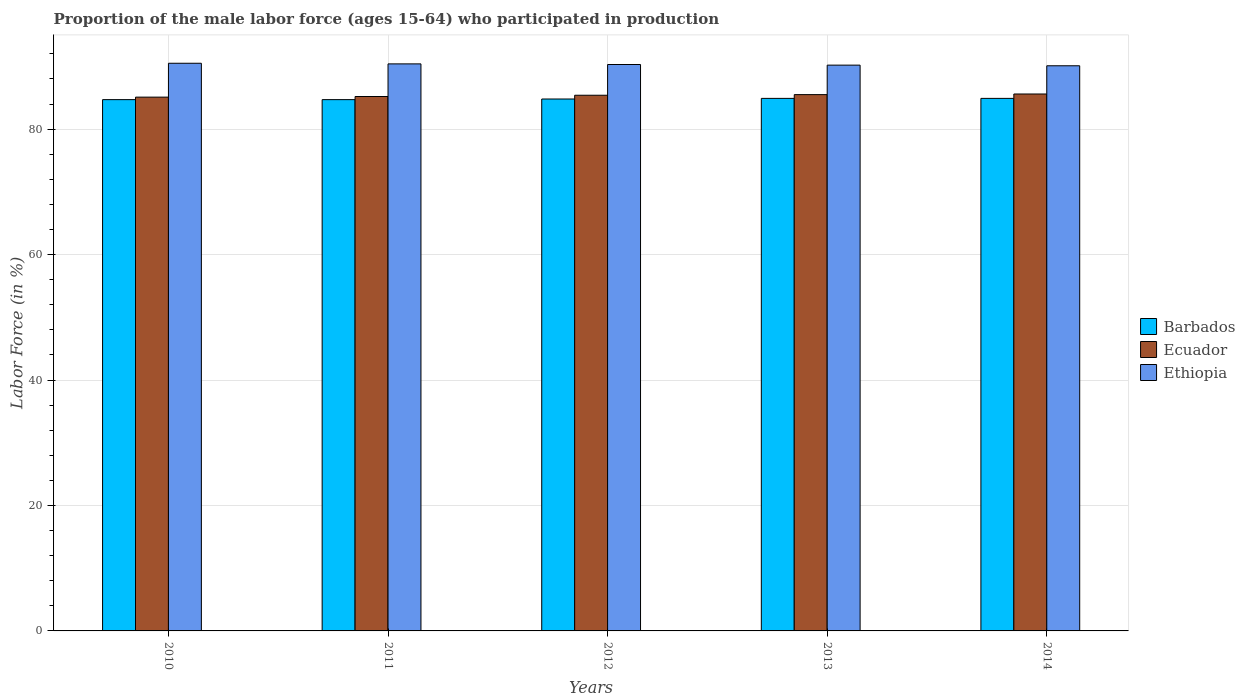How many groups of bars are there?
Your answer should be very brief. 5. Are the number of bars per tick equal to the number of legend labels?
Your answer should be very brief. Yes. Are the number of bars on each tick of the X-axis equal?
Your answer should be very brief. Yes. How many bars are there on the 3rd tick from the left?
Offer a very short reply. 3. In how many cases, is the number of bars for a given year not equal to the number of legend labels?
Your answer should be compact. 0. What is the proportion of the male labor force who participated in production in Barbados in 2012?
Offer a terse response. 84.8. Across all years, what is the maximum proportion of the male labor force who participated in production in Barbados?
Ensure brevity in your answer.  84.9. Across all years, what is the minimum proportion of the male labor force who participated in production in Barbados?
Ensure brevity in your answer.  84.7. In which year was the proportion of the male labor force who participated in production in Ethiopia maximum?
Ensure brevity in your answer.  2010. In which year was the proportion of the male labor force who participated in production in Barbados minimum?
Your answer should be compact. 2010. What is the total proportion of the male labor force who participated in production in Ethiopia in the graph?
Your answer should be compact. 451.5. What is the difference between the proportion of the male labor force who participated in production in Ethiopia in 2010 and that in 2012?
Provide a succinct answer. 0.2. What is the difference between the proportion of the male labor force who participated in production in Barbados in 2012 and the proportion of the male labor force who participated in production in Ethiopia in 2013?
Keep it short and to the point. -5.4. What is the average proportion of the male labor force who participated in production in Barbados per year?
Your answer should be compact. 84.8. In the year 2013, what is the difference between the proportion of the male labor force who participated in production in Barbados and proportion of the male labor force who participated in production in Ecuador?
Provide a succinct answer. -0.6. In how many years, is the proportion of the male labor force who participated in production in Ethiopia greater than 16 %?
Give a very brief answer. 5. What is the ratio of the proportion of the male labor force who participated in production in Barbados in 2011 to that in 2012?
Your answer should be very brief. 1. Is the difference between the proportion of the male labor force who participated in production in Barbados in 2010 and 2014 greater than the difference between the proportion of the male labor force who participated in production in Ecuador in 2010 and 2014?
Provide a short and direct response. Yes. What is the difference between the highest and the second highest proportion of the male labor force who participated in production in Ecuador?
Provide a succinct answer. 0.1. What is the difference between the highest and the lowest proportion of the male labor force who participated in production in Ethiopia?
Your response must be concise. 0.4. What does the 1st bar from the left in 2013 represents?
Your answer should be very brief. Barbados. What does the 1st bar from the right in 2010 represents?
Give a very brief answer. Ethiopia. Is it the case that in every year, the sum of the proportion of the male labor force who participated in production in Ethiopia and proportion of the male labor force who participated in production in Barbados is greater than the proportion of the male labor force who participated in production in Ecuador?
Your response must be concise. Yes. How many bars are there?
Ensure brevity in your answer.  15. Are all the bars in the graph horizontal?
Offer a terse response. No. How many years are there in the graph?
Your answer should be very brief. 5. Are the values on the major ticks of Y-axis written in scientific E-notation?
Ensure brevity in your answer.  No. Does the graph contain any zero values?
Make the answer very short. No. Where does the legend appear in the graph?
Provide a short and direct response. Center right. What is the title of the graph?
Ensure brevity in your answer.  Proportion of the male labor force (ages 15-64) who participated in production. What is the label or title of the X-axis?
Your response must be concise. Years. What is the Labor Force (in %) of Barbados in 2010?
Make the answer very short. 84.7. What is the Labor Force (in %) of Ecuador in 2010?
Make the answer very short. 85.1. What is the Labor Force (in %) in Ethiopia in 2010?
Give a very brief answer. 90.5. What is the Labor Force (in %) of Barbados in 2011?
Offer a terse response. 84.7. What is the Labor Force (in %) of Ecuador in 2011?
Make the answer very short. 85.2. What is the Labor Force (in %) in Ethiopia in 2011?
Offer a very short reply. 90.4. What is the Labor Force (in %) of Barbados in 2012?
Your answer should be very brief. 84.8. What is the Labor Force (in %) in Ecuador in 2012?
Keep it short and to the point. 85.4. What is the Labor Force (in %) in Ethiopia in 2012?
Offer a terse response. 90.3. What is the Labor Force (in %) of Barbados in 2013?
Make the answer very short. 84.9. What is the Labor Force (in %) of Ecuador in 2013?
Your answer should be compact. 85.5. What is the Labor Force (in %) in Ethiopia in 2013?
Your answer should be very brief. 90.2. What is the Labor Force (in %) in Barbados in 2014?
Ensure brevity in your answer.  84.9. What is the Labor Force (in %) of Ecuador in 2014?
Your response must be concise. 85.6. What is the Labor Force (in %) in Ethiopia in 2014?
Offer a terse response. 90.1. Across all years, what is the maximum Labor Force (in %) in Barbados?
Your answer should be compact. 84.9. Across all years, what is the maximum Labor Force (in %) in Ecuador?
Ensure brevity in your answer.  85.6. Across all years, what is the maximum Labor Force (in %) of Ethiopia?
Offer a terse response. 90.5. Across all years, what is the minimum Labor Force (in %) of Barbados?
Ensure brevity in your answer.  84.7. Across all years, what is the minimum Labor Force (in %) in Ecuador?
Provide a succinct answer. 85.1. Across all years, what is the minimum Labor Force (in %) of Ethiopia?
Keep it short and to the point. 90.1. What is the total Labor Force (in %) in Barbados in the graph?
Give a very brief answer. 424. What is the total Labor Force (in %) in Ecuador in the graph?
Your answer should be compact. 426.8. What is the total Labor Force (in %) in Ethiopia in the graph?
Give a very brief answer. 451.5. What is the difference between the Labor Force (in %) of Ethiopia in 2010 and that in 2011?
Give a very brief answer. 0.1. What is the difference between the Labor Force (in %) of Ethiopia in 2010 and that in 2014?
Make the answer very short. 0.4. What is the difference between the Labor Force (in %) in Ecuador in 2011 and that in 2012?
Give a very brief answer. -0.2. What is the difference between the Labor Force (in %) of Ethiopia in 2011 and that in 2012?
Ensure brevity in your answer.  0.1. What is the difference between the Labor Force (in %) in Ethiopia in 2011 and that in 2014?
Give a very brief answer. 0.3. What is the difference between the Labor Force (in %) in Barbados in 2012 and that in 2013?
Your answer should be very brief. -0.1. What is the difference between the Labor Force (in %) in Barbados in 2012 and that in 2014?
Provide a succinct answer. -0.1. What is the difference between the Labor Force (in %) of Ecuador in 2012 and that in 2014?
Give a very brief answer. -0.2. What is the difference between the Labor Force (in %) of Ethiopia in 2012 and that in 2014?
Offer a very short reply. 0.2. What is the difference between the Labor Force (in %) of Barbados in 2013 and that in 2014?
Ensure brevity in your answer.  0. What is the difference between the Labor Force (in %) in Ethiopia in 2013 and that in 2014?
Give a very brief answer. 0.1. What is the difference between the Labor Force (in %) of Barbados in 2010 and the Labor Force (in %) of Ecuador in 2011?
Provide a succinct answer. -0.5. What is the difference between the Labor Force (in %) of Ecuador in 2010 and the Labor Force (in %) of Ethiopia in 2011?
Provide a short and direct response. -5.3. What is the difference between the Labor Force (in %) of Barbados in 2010 and the Labor Force (in %) of Ethiopia in 2012?
Make the answer very short. -5.6. What is the difference between the Labor Force (in %) in Ecuador in 2010 and the Labor Force (in %) in Ethiopia in 2012?
Ensure brevity in your answer.  -5.2. What is the difference between the Labor Force (in %) in Barbados in 2010 and the Labor Force (in %) in Ethiopia in 2013?
Give a very brief answer. -5.5. What is the difference between the Labor Force (in %) in Barbados in 2010 and the Labor Force (in %) in Ecuador in 2014?
Offer a very short reply. -0.9. What is the difference between the Labor Force (in %) of Barbados in 2010 and the Labor Force (in %) of Ethiopia in 2014?
Offer a terse response. -5.4. What is the difference between the Labor Force (in %) of Ecuador in 2010 and the Labor Force (in %) of Ethiopia in 2014?
Give a very brief answer. -5. What is the difference between the Labor Force (in %) in Barbados in 2011 and the Labor Force (in %) in Ethiopia in 2012?
Keep it short and to the point. -5.6. What is the difference between the Labor Force (in %) in Barbados in 2011 and the Labor Force (in %) in Ecuador in 2013?
Keep it short and to the point. -0.8. What is the difference between the Labor Force (in %) of Barbados in 2011 and the Labor Force (in %) of Ethiopia in 2013?
Your answer should be compact. -5.5. What is the difference between the Labor Force (in %) of Barbados in 2011 and the Labor Force (in %) of Ecuador in 2014?
Your answer should be compact. -0.9. What is the difference between the Labor Force (in %) of Barbados in 2012 and the Labor Force (in %) of Ethiopia in 2013?
Make the answer very short. -5.4. What is the difference between the Labor Force (in %) of Barbados in 2012 and the Labor Force (in %) of Ecuador in 2014?
Offer a very short reply. -0.8. What is the difference between the Labor Force (in %) in Barbados in 2012 and the Labor Force (in %) in Ethiopia in 2014?
Provide a short and direct response. -5.3. What is the difference between the Labor Force (in %) of Ecuador in 2012 and the Labor Force (in %) of Ethiopia in 2014?
Keep it short and to the point. -4.7. What is the difference between the Labor Force (in %) in Ecuador in 2013 and the Labor Force (in %) in Ethiopia in 2014?
Make the answer very short. -4.6. What is the average Labor Force (in %) of Barbados per year?
Your response must be concise. 84.8. What is the average Labor Force (in %) of Ecuador per year?
Your response must be concise. 85.36. What is the average Labor Force (in %) in Ethiopia per year?
Provide a short and direct response. 90.3. In the year 2010, what is the difference between the Labor Force (in %) in Barbados and Labor Force (in %) in Ecuador?
Offer a very short reply. -0.4. In the year 2010, what is the difference between the Labor Force (in %) of Barbados and Labor Force (in %) of Ethiopia?
Your answer should be very brief. -5.8. In the year 2011, what is the difference between the Labor Force (in %) of Barbados and Labor Force (in %) of Ecuador?
Offer a terse response. -0.5. In the year 2011, what is the difference between the Labor Force (in %) in Ecuador and Labor Force (in %) in Ethiopia?
Make the answer very short. -5.2. In the year 2012, what is the difference between the Labor Force (in %) of Barbados and Labor Force (in %) of Ecuador?
Make the answer very short. -0.6. In the year 2012, what is the difference between the Labor Force (in %) of Barbados and Labor Force (in %) of Ethiopia?
Your response must be concise. -5.5. In the year 2013, what is the difference between the Labor Force (in %) of Barbados and Labor Force (in %) of Ecuador?
Make the answer very short. -0.6. In the year 2013, what is the difference between the Labor Force (in %) in Barbados and Labor Force (in %) in Ethiopia?
Ensure brevity in your answer.  -5.3. In the year 2013, what is the difference between the Labor Force (in %) in Ecuador and Labor Force (in %) in Ethiopia?
Give a very brief answer. -4.7. What is the ratio of the Labor Force (in %) of Ethiopia in 2010 to that in 2011?
Give a very brief answer. 1. What is the ratio of the Labor Force (in %) of Ecuador in 2010 to that in 2013?
Your answer should be compact. 1. What is the ratio of the Labor Force (in %) of Ecuador in 2010 to that in 2014?
Keep it short and to the point. 0.99. What is the ratio of the Labor Force (in %) of Ecuador in 2011 to that in 2012?
Provide a short and direct response. 1. What is the ratio of the Labor Force (in %) of Ethiopia in 2011 to that in 2012?
Your answer should be very brief. 1. What is the ratio of the Labor Force (in %) in Barbados in 2011 to that in 2013?
Your answer should be very brief. 1. What is the ratio of the Labor Force (in %) in Ecuador in 2011 to that in 2013?
Offer a very short reply. 1. What is the ratio of the Labor Force (in %) of Ethiopia in 2011 to that in 2013?
Ensure brevity in your answer.  1. What is the ratio of the Labor Force (in %) of Ecuador in 2011 to that in 2014?
Your response must be concise. 1. What is the ratio of the Labor Force (in %) in Ethiopia in 2011 to that in 2014?
Offer a terse response. 1. What is the ratio of the Labor Force (in %) of Ecuador in 2012 to that in 2013?
Make the answer very short. 1. What is the ratio of the Labor Force (in %) in Ethiopia in 2012 to that in 2013?
Your answer should be very brief. 1. What is the ratio of the Labor Force (in %) of Barbados in 2012 to that in 2014?
Your response must be concise. 1. What is the ratio of the Labor Force (in %) in Ethiopia in 2012 to that in 2014?
Keep it short and to the point. 1. What is the ratio of the Labor Force (in %) in Barbados in 2013 to that in 2014?
Your answer should be very brief. 1. What is the difference between the highest and the second highest Labor Force (in %) of Ecuador?
Provide a succinct answer. 0.1. What is the difference between the highest and the lowest Labor Force (in %) in Ethiopia?
Offer a terse response. 0.4. 